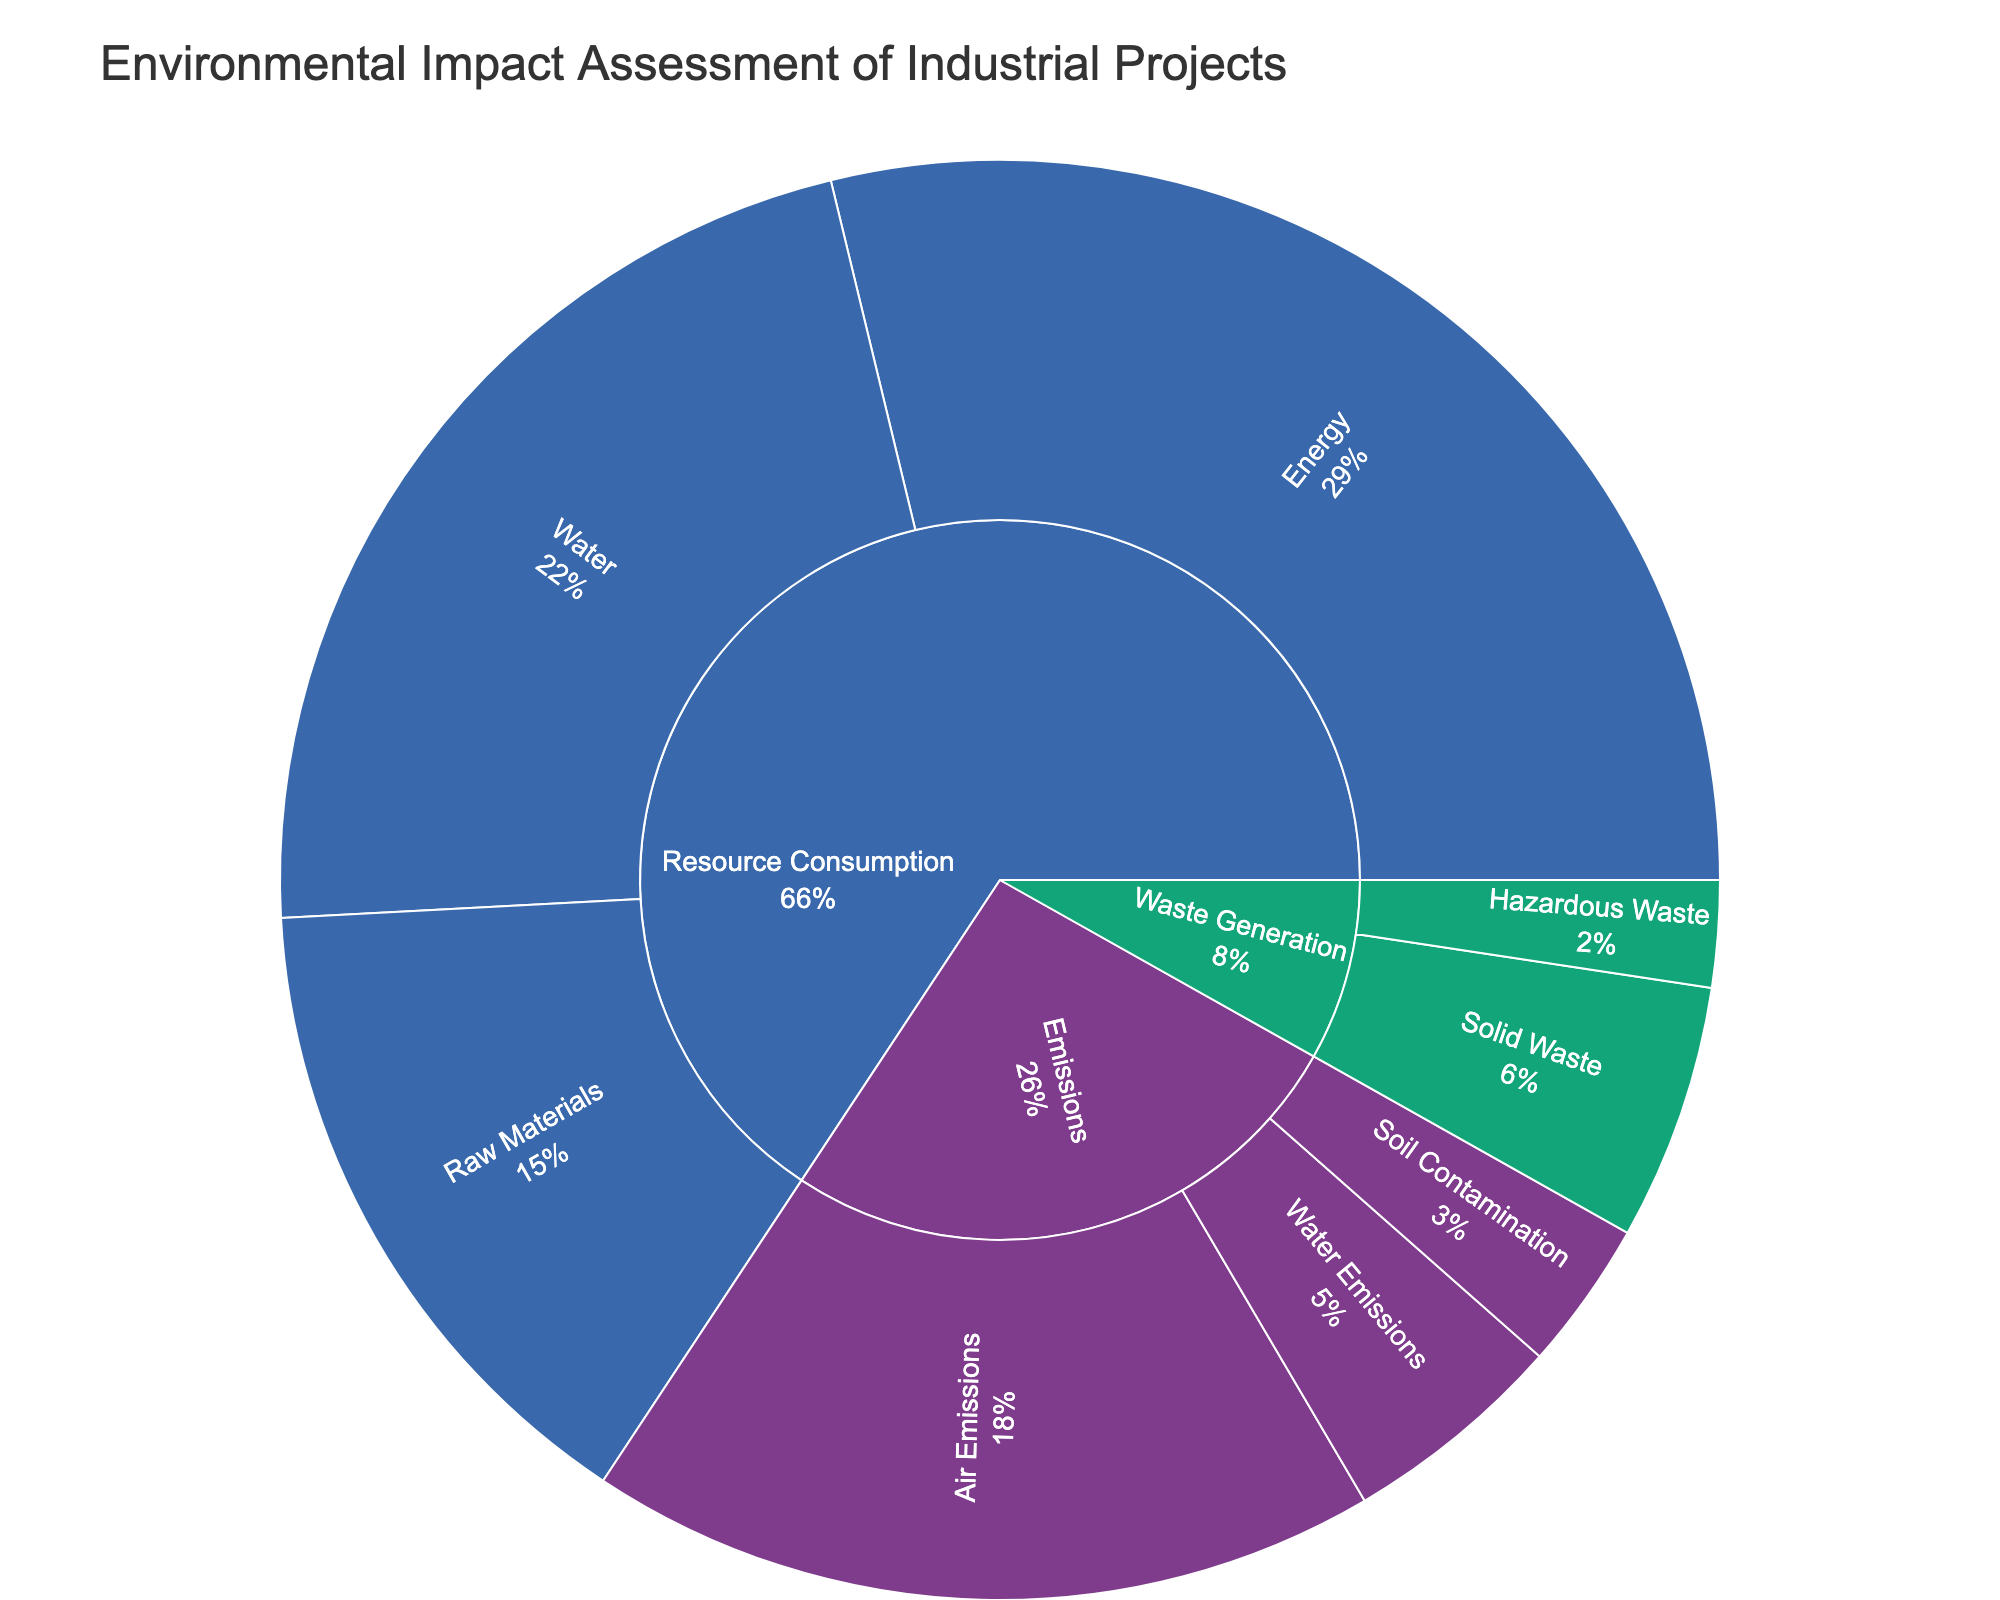what is the title of the plot? The title of the plot is located at the top and is often the largest text size in the visual. In this case, the title indicates the focus of the environmental assessment.
Answer: Environmental Impact Assessment of Industrial Projects which category has the largest contribution to environmental impact in the plot? The largest category can be identified by the size of its segment in the sunburst plot. Comparing the values or areas directly, one can see which is the largest.
Answer: Resource Consumption what is the total value of water-related categories in emissions? Sum the values of all items related to water emissions. These include Suspended Solids, Nitrogen, and Phosphorus. Calculate the total: 300 (Suspended Solids) + 150 (Nitrogen) + 75 (Phosphorus) = 525.
Answer: 525 how does the value of Carbon Dioxide emissions compare with the value of Process Water consumption? Compare the value of Carbon Dioxide emissions (1500) with the value of Process Water consumption (1500). Observe that both values are the same.
Answer: Equal what is the smallest item within the Raw Materials subcategory? Look at the values within the Raw Materials subcategory: Steel (500), Concrete (750), and Chemicals (300). Identify the smallest value.
Answer: Chemicals which subcategory within Waste Generation has the highest total value? Sum the values of items in each subcategory under Waste Generation: Solid Waste (400 + 200 = 600) and Hazardous Waste (150 + 100 = 250). The highest total value will indicate the subcategory.
Answer: Solid Waste is there any subcategory within Emissions where all values combined are less than 300? Evaluate each subcategory under Emissions. For example, Soil Contamination: add Heavy Metals (200) and Hydrocarbons (150), resulting in 350, which is more than 300. Similarly add values in other subcategories.
Answer: None what percentage of the total impact does Electricity consumption account for? First find the total of all values, then calculate the percentage of Electricity (2000). Total = sum of all values from the data table. Then use (2000 / Total) * 100%.
Answer: Approximately 25% which is more significant: the total emissions from Air Emissions or Resource Consumption in Energy? Sum values under Air Emissions (Carbon Dioxide, Methane, Nitrous Oxide) and compare with the sum under Energy (Electricity and Natural Gas). Air Emissions: 1500 + 250 + 100 = 1850. Energy: 2000 + 1000 = 3000.
Answer: Resource Consumption in Energy 